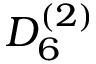<formula> <loc_0><loc_0><loc_500><loc_500>{ D } _ { 6 } ^ { ( 2 ) }</formula> 